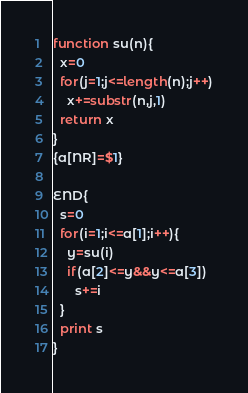<code> <loc_0><loc_0><loc_500><loc_500><_Awk_>function su(n){
  x=0
  for(j=1;j<=length(n);j++)
    x+=substr(n,j,1)
  return x
}
{a[NR]=$1}

END{
  s=0
  for(i=1;i<=a[1];i++){
    y=su(i)
    if(a[2]<=y&&y<=a[3])
      s+=i
  }
  print s
}</code> 